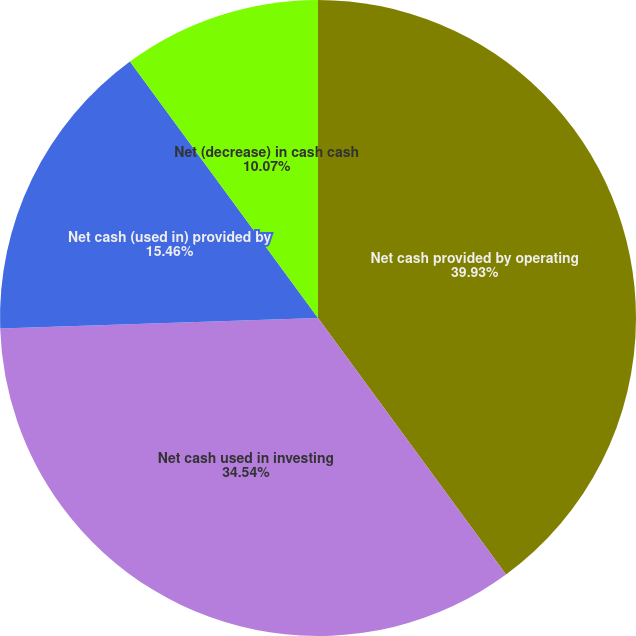<chart> <loc_0><loc_0><loc_500><loc_500><pie_chart><fcel>Net cash provided by operating<fcel>Net cash used in investing<fcel>Net cash (used in) provided by<fcel>Net (decrease) in cash cash<nl><fcel>39.93%<fcel>34.54%<fcel>15.46%<fcel>10.07%<nl></chart> 